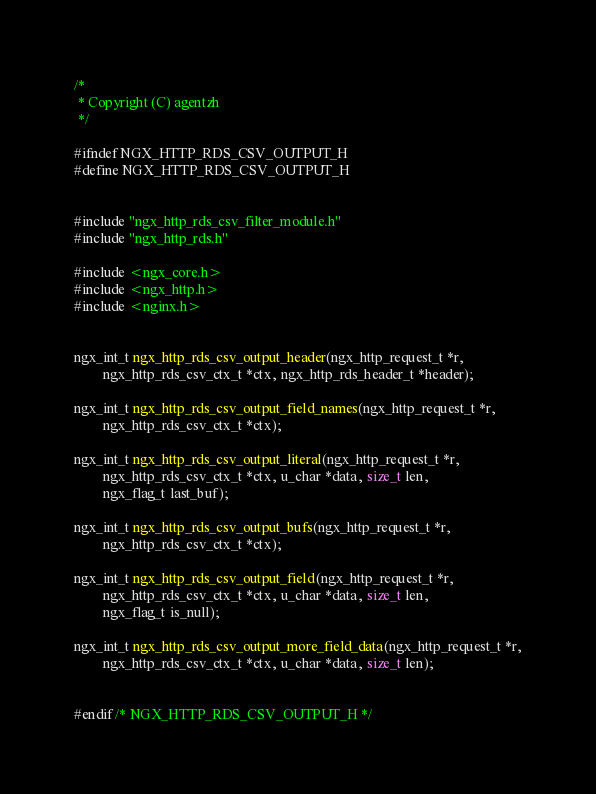<code> <loc_0><loc_0><loc_500><loc_500><_C_>
/*
 * Copyright (C) agentzh
 */

#ifndef NGX_HTTP_RDS_CSV_OUTPUT_H
#define NGX_HTTP_RDS_CSV_OUTPUT_H


#include "ngx_http_rds_csv_filter_module.h"
#include "ngx_http_rds.h"

#include <ngx_core.h>
#include <ngx_http.h>
#include <nginx.h>


ngx_int_t ngx_http_rds_csv_output_header(ngx_http_request_t *r,
        ngx_http_rds_csv_ctx_t *ctx, ngx_http_rds_header_t *header);

ngx_int_t ngx_http_rds_csv_output_field_names(ngx_http_request_t *r,
        ngx_http_rds_csv_ctx_t *ctx);

ngx_int_t ngx_http_rds_csv_output_literal(ngx_http_request_t *r,
        ngx_http_rds_csv_ctx_t *ctx, u_char *data, size_t len,
        ngx_flag_t last_buf);

ngx_int_t ngx_http_rds_csv_output_bufs(ngx_http_request_t *r,
        ngx_http_rds_csv_ctx_t *ctx);

ngx_int_t ngx_http_rds_csv_output_field(ngx_http_request_t *r,
        ngx_http_rds_csv_ctx_t *ctx, u_char *data, size_t len,
        ngx_flag_t is_null);

ngx_int_t ngx_http_rds_csv_output_more_field_data(ngx_http_request_t *r,
        ngx_http_rds_csv_ctx_t *ctx, u_char *data, size_t len);


#endif /* NGX_HTTP_RDS_CSV_OUTPUT_H */

</code> 